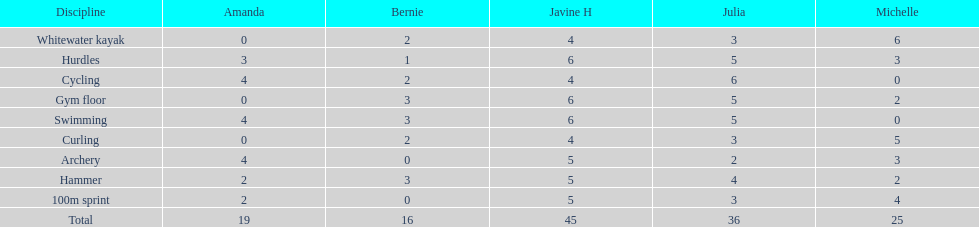Who is the quickest runner? Javine H. 